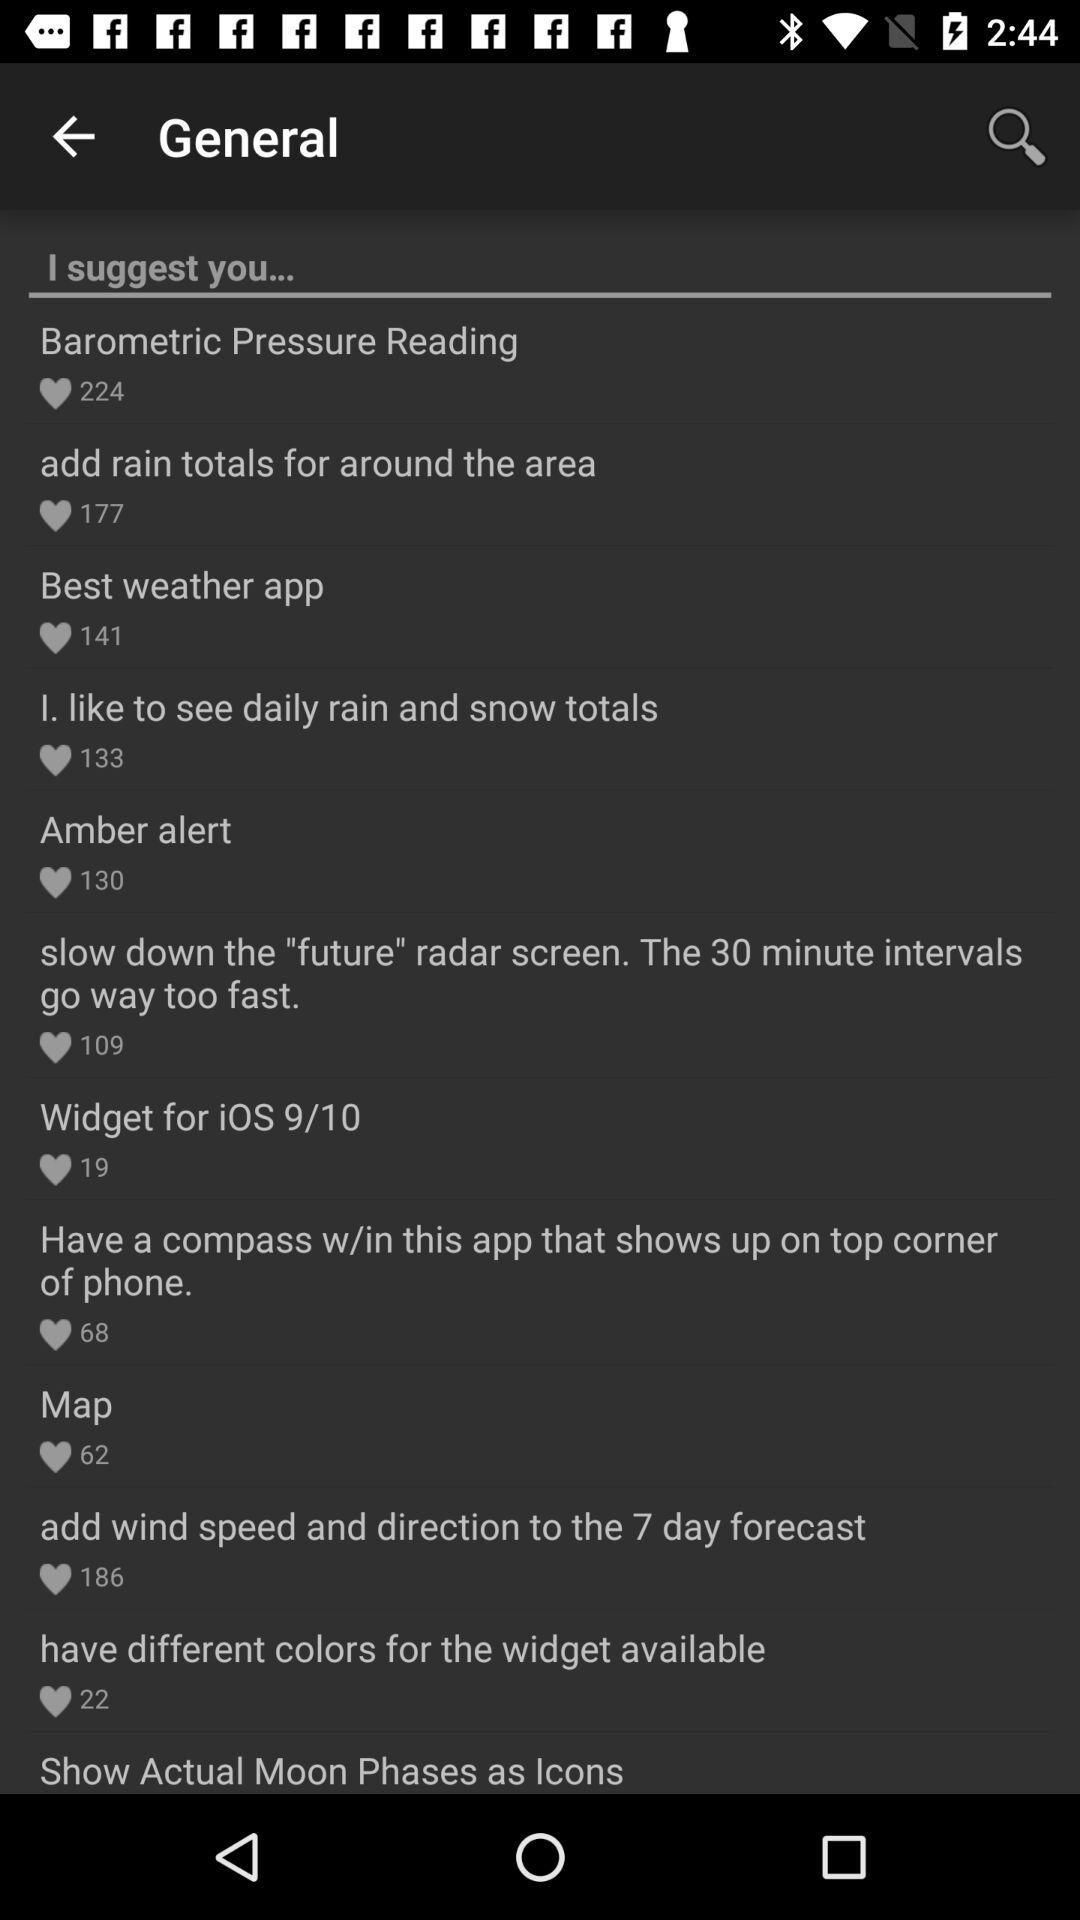How many people liked the "Widget for iOS 9/10" suggestion? The suggestion "Widget for iOS 9/10" is liked by 19 people. 